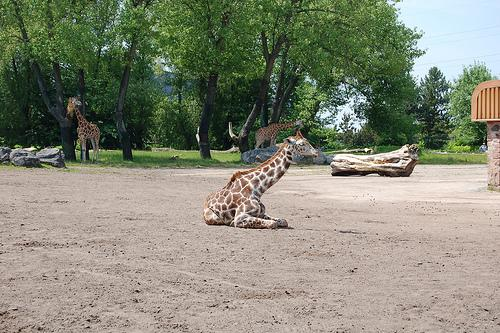Question: what animals are shown?
Choices:
A. Horses.
B. Giraffes.
C. Cats.
D. Dogs.
Answer with the letter. Answer: B Question: how many giraffes are present?
Choices:
A. One.
B. Three.
C. Two.
D. Six.
Answer with the letter. Answer: C Question: where is this picture taken?
Choices:
A. Circus.
B. A zoo.
C. Beach.
D. Carnival.
Answer with the letter. Answer: B Question: what color are the giraffes?
Choices:
A. Brown and white.
B. Yellow.
C. Red.
D. Orange.
Answer with the letter. Answer: A Question: what color are the trees?
Choices:
A. Gray.
B. Brown.
C. Green.
D. Black.
Answer with the letter. Answer: C 